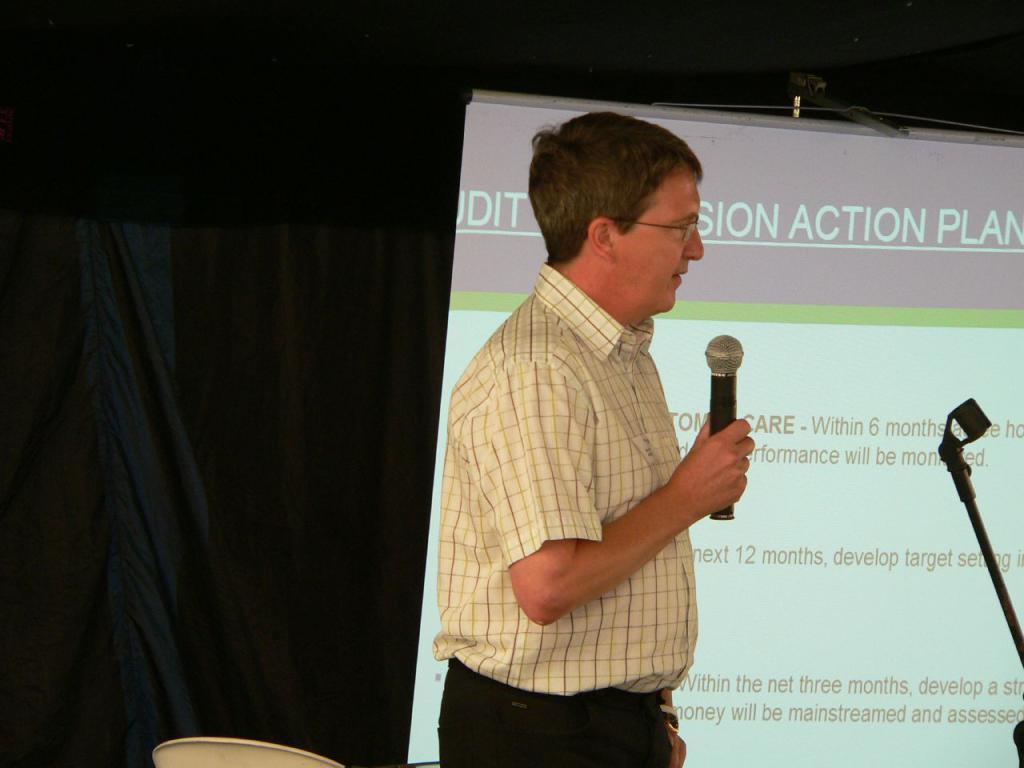Please provide a concise description of this image. In this image we can see a man standing holding a mic. We can also see a curtain, chair and a display screen with some text on it. On the right side we can see a stand. 